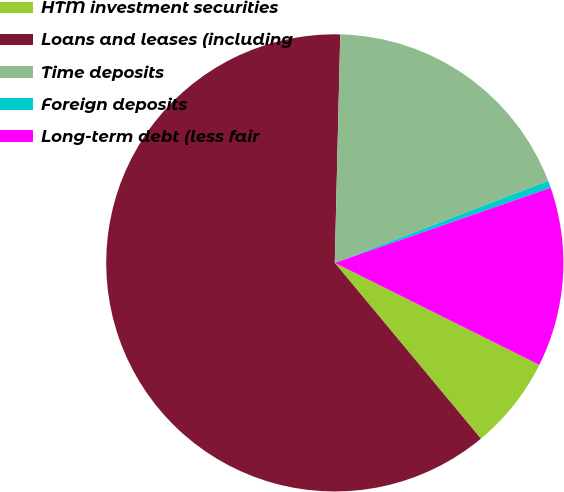<chart> <loc_0><loc_0><loc_500><loc_500><pie_chart><fcel>HTM investment securities<fcel>Loans and leases (including<fcel>Time deposits<fcel>Foreign deposits<fcel>Long-term debt (less fair<nl><fcel>6.6%<fcel>61.42%<fcel>18.78%<fcel>0.51%<fcel>12.69%<nl></chart> 